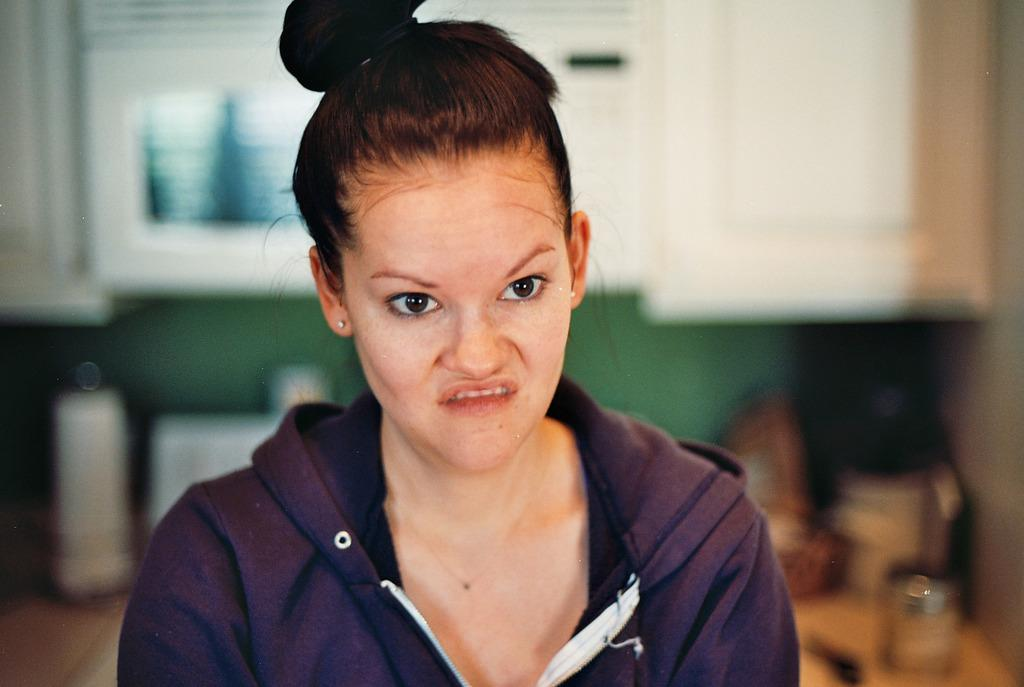Who is the main subject in the image? There is a lady in the center of the image. What can be seen in the background of the image? There are objects and a wall in the background of the image. Can you describe the objects in the background? There is a cupboard in the background of the image. What part of the floor is visible in the image? The floor is visible at the bottom left corner of the image. What type of rod is being used to weigh the objects in the image? There is no rod or scale present in the image, and therefore no such activity can be observed. 